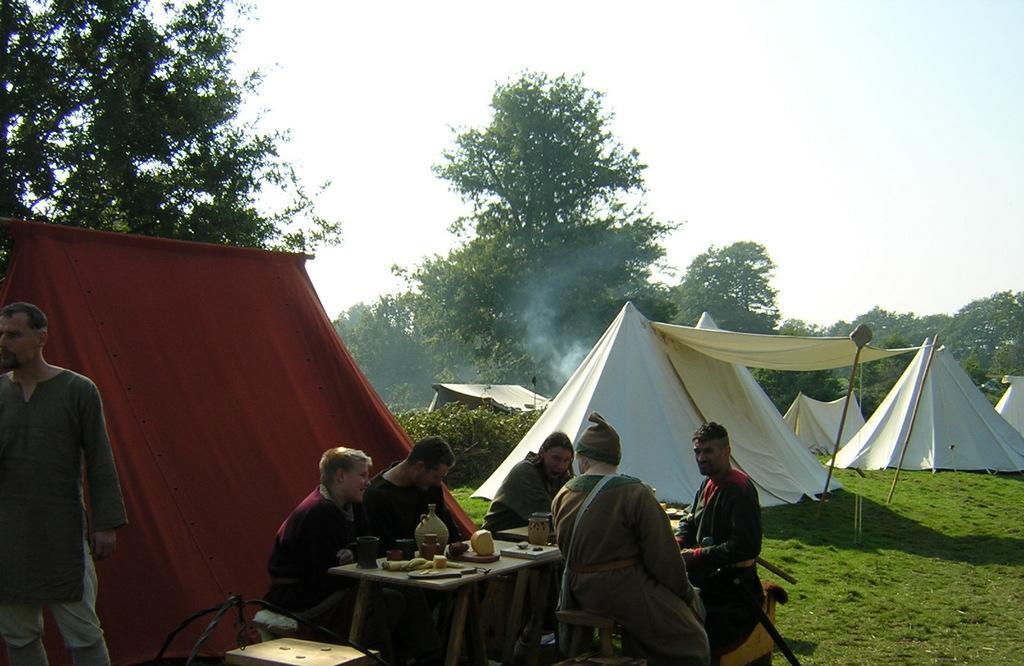Describe this image in one or two sentences. Here we can see a group of people sitting on chairs near a table with food on it and there are number of tents built and there are trees and sky is clear 